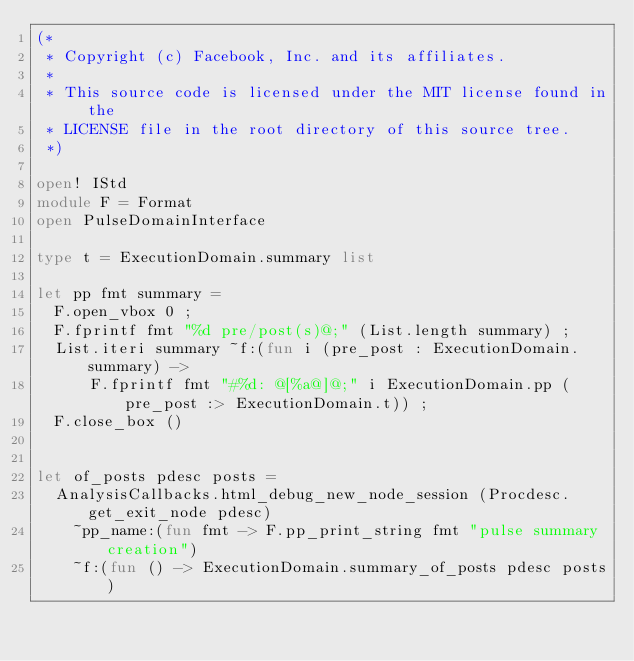<code> <loc_0><loc_0><loc_500><loc_500><_OCaml_>(*
 * Copyright (c) Facebook, Inc. and its affiliates.
 *
 * This source code is licensed under the MIT license found in the
 * LICENSE file in the root directory of this source tree.
 *)

open! IStd
module F = Format
open PulseDomainInterface

type t = ExecutionDomain.summary list

let pp fmt summary =
  F.open_vbox 0 ;
  F.fprintf fmt "%d pre/post(s)@;" (List.length summary) ;
  List.iteri summary ~f:(fun i (pre_post : ExecutionDomain.summary) ->
      F.fprintf fmt "#%d: @[%a@]@;" i ExecutionDomain.pp (pre_post :> ExecutionDomain.t)) ;
  F.close_box ()


let of_posts pdesc posts =
  AnalysisCallbacks.html_debug_new_node_session (Procdesc.get_exit_node pdesc)
    ~pp_name:(fun fmt -> F.pp_print_string fmt "pulse summary creation")
    ~f:(fun () -> ExecutionDomain.summary_of_posts pdesc posts)
</code> 